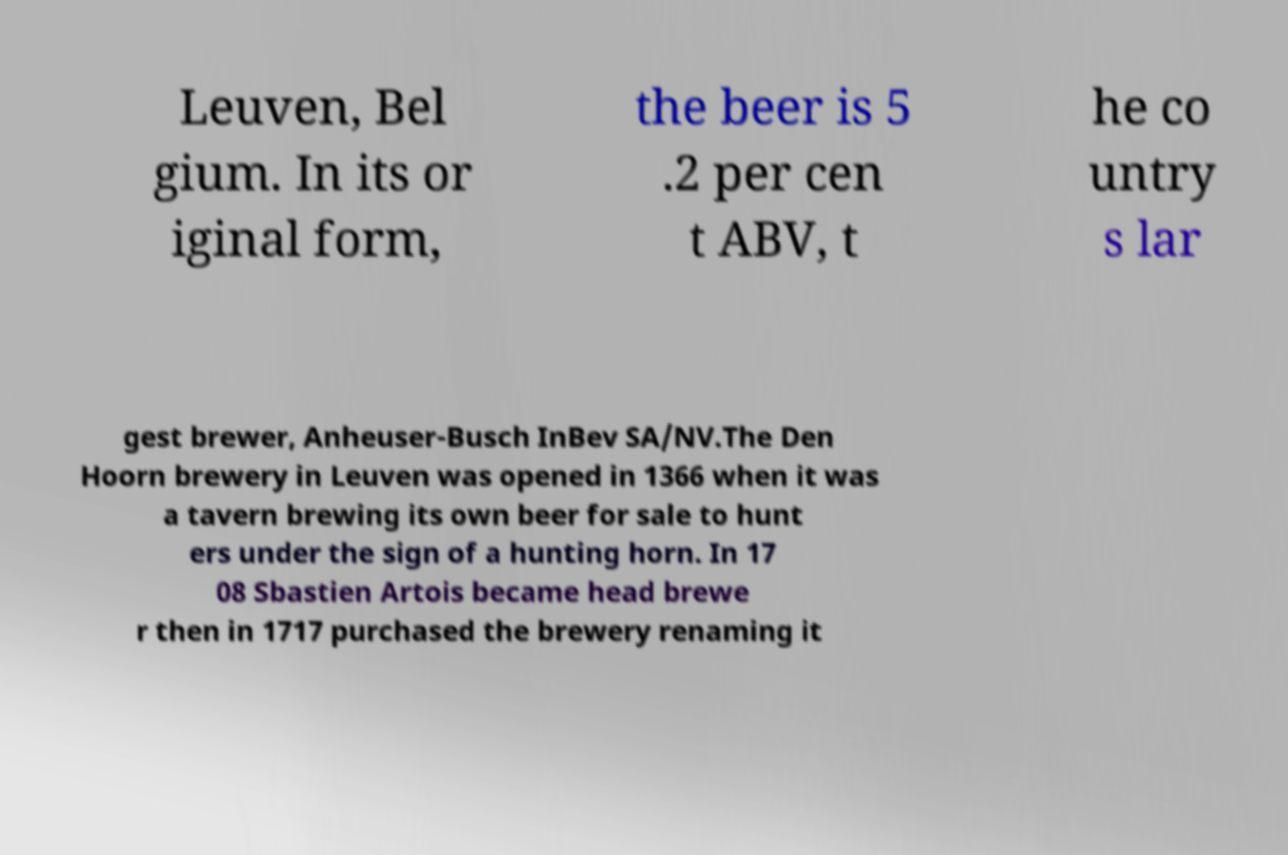Can you accurately transcribe the text from the provided image for me? Leuven, Bel gium. In its or iginal form, the beer is 5 .2 per cen t ABV, t he co untry s lar gest brewer, Anheuser-Busch InBev SA/NV.The Den Hoorn brewery in Leuven was opened in 1366 when it was a tavern brewing its own beer for sale to hunt ers under the sign of a hunting horn. In 17 08 Sbastien Artois became head brewe r then in 1717 purchased the brewery renaming it 